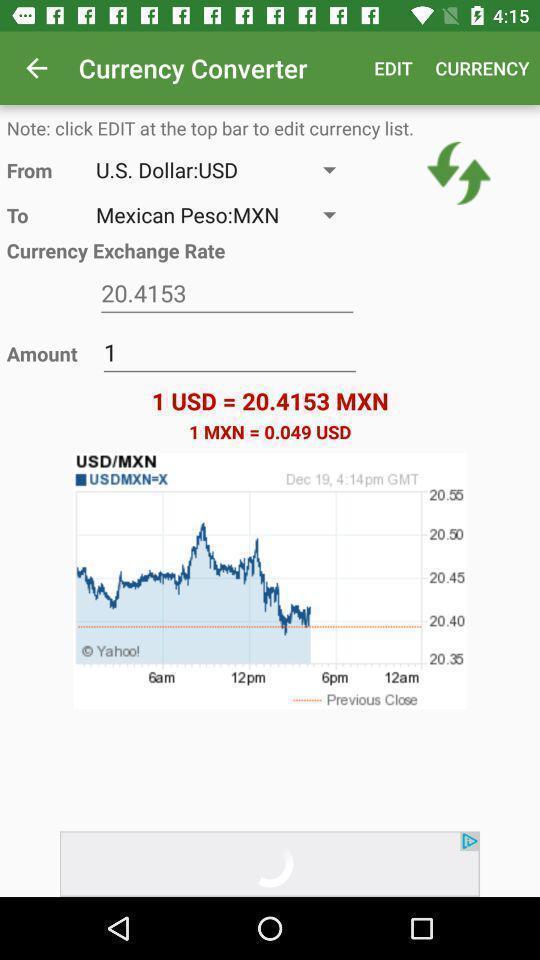Tell me about the visual elements in this screen capture. Page displaying with option to convert the currency. 